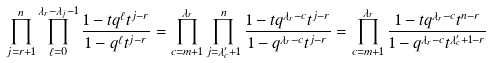<formula> <loc_0><loc_0><loc_500><loc_500>\prod _ { j = r + 1 } ^ { n } \prod _ { \ell = 0 } ^ { \lambda _ { r } - \lambda _ { j } - 1 } \frac { 1 - t q ^ { \ell } t ^ { j - r } } { 1 - q ^ { \ell } t ^ { j - r } } = \prod _ { c = m + 1 } ^ { \lambda _ { r } } \prod _ { j = \lambda _ { c } ^ { \prime } + 1 } ^ { n } \frac { 1 - t q ^ { \lambda _ { r } - c } t ^ { j - r } } { 1 - q ^ { \lambda _ { r } - c } t ^ { j - r } } = \prod _ { c = m + 1 } ^ { \lambda _ { r } } \frac { 1 - t q ^ { \lambda _ { r } - c } t ^ { n - r } } { 1 - q ^ { \lambda _ { r } - c } t ^ { \lambda ^ { \prime } _ { c } + 1 - r } }</formula> 